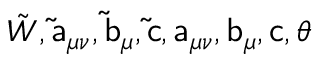<formula> <loc_0><loc_0><loc_500><loc_500>{ \tilde { W } } , \tilde { a } _ { \mu \nu } , \tilde { b } _ { \mu } , \tilde { c } , a _ { \mu \nu } , b _ { \mu } , c , \theta</formula> 